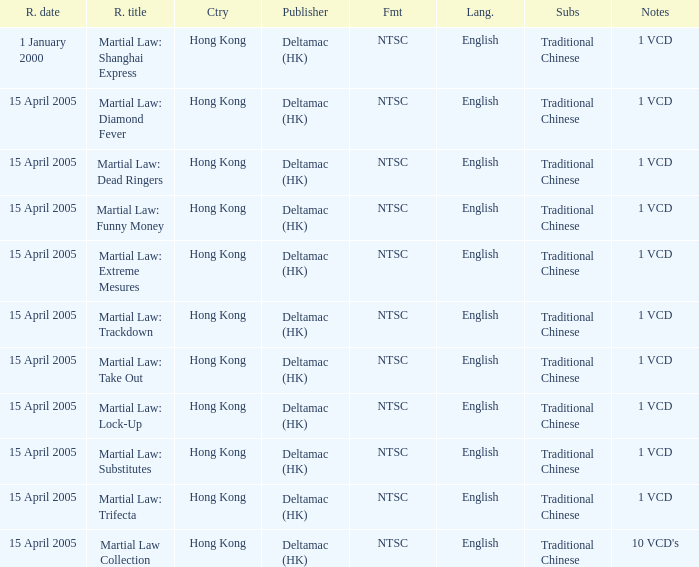Which publisher released Martial Law: Substitutes? Deltamac (HK). Give me the full table as a dictionary. {'header': ['R. date', 'R. title', 'Ctry', 'Publisher', 'Fmt', 'Lang.', 'Subs', 'Notes'], 'rows': [['1 January 2000', 'Martial Law: Shanghai Express', 'Hong Kong', 'Deltamac (HK)', 'NTSC', 'English', 'Traditional Chinese', '1 VCD'], ['15 April 2005', 'Martial Law: Diamond Fever', 'Hong Kong', 'Deltamac (HK)', 'NTSC', 'English', 'Traditional Chinese', '1 VCD'], ['15 April 2005', 'Martial Law: Dead Ringers', 'Hong Kong', 'Deltamac (HK)', 'NTSC', 'English', 'Traditional Chinese', '1 VCD'], ['15 April 2005', 'Martial Law: Funny Money', 'Hong Kong', 'Deltamac (HK)', 'NTSC', 'English', 'Traditional Chinese', '1 VCD'], ['15 April 2005', 'Martial Law: Extreme Mesures', 'Hong Kong', 'Deltamac (HK)', 'NTSC', 'English', 'Traditional Chinese', '1 VCD'], ['15 April 2005', 'Martial Law: Trackdown', 'Hong Kong', 'Deltamac (HK)', 'NTSC', 'English', 'Traditional Chinese', '1 VCD'], ['15 April 2005', 'Martial Law: Take Out', 'Hong Kong', 'Deltamac (HK)', 'NTSC', 'English', 'Traditional Chinese', '1 VCD'], ['15 April 2005', 'Martial Law: Lock-Up', 'Hong Kong', 'Deltamac (HK)', 'NTSC', 'English', 'Traditional Chinese', '1 VCD'], ['15 April 2005', 'Martial Law: Substitutes', 'Hong Kong', 'Deltamac (HK)', 'NTSC', 'English', 'Traditional Chinese', '1 VCD'], ['15 April 2005', 'Martial Law: Trifecta', 'Hong Kong', 'Deltamac (HK)', 'NTSC', 'English', 'Traditional Chinese', '1 VCD'], ['15 April 2005', 'Martial Law Collection', 'Hong Kong', 'Deltamac (HK)', 'NTSC', 'English', 'Traditional Chinese', "10 VCD's"]]} 